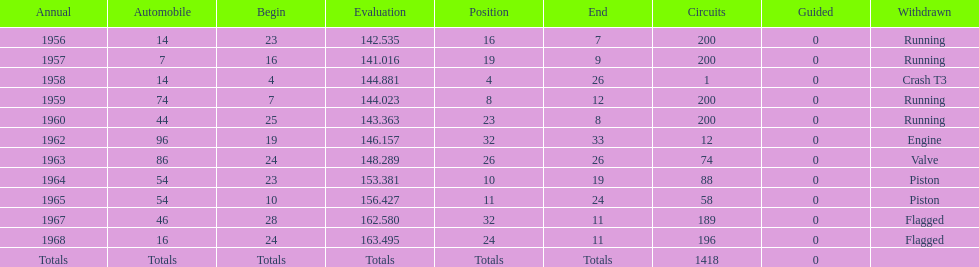What is the larger laps between 1963 or 1968 1968. 